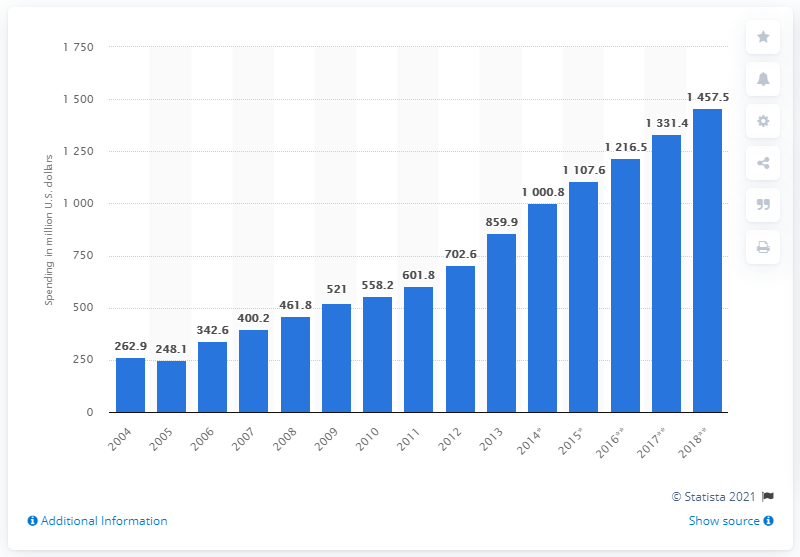Based on the chart, which years saw the greatest growth in ad spending, and what might this indicate about the market at that time? The chart points to significant growth in ad spending between 2015 and 2016, where expenditure jumped from 1,000.8 million to 1,216.5 million US dollars. This sharp increase may indicate a booming market at the time, with high consumer confidence and an influx of foreign investment driving up the demand for advertising. 